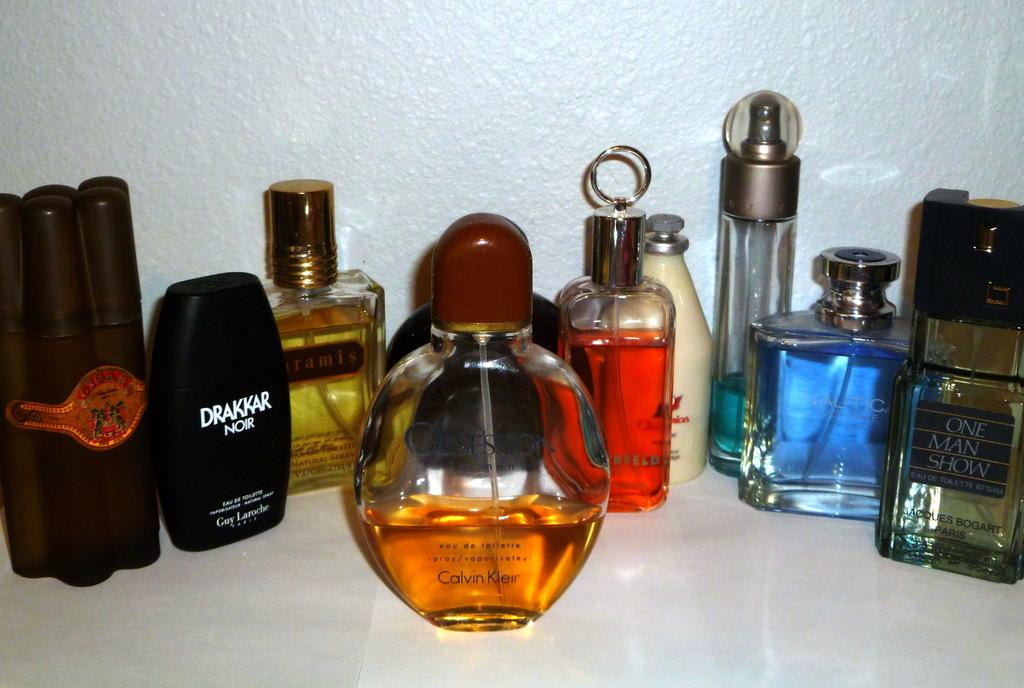<image>
Relay a brief, clear account of the picture shown. A group of perfume bottles on a table, one is Drakkar. 